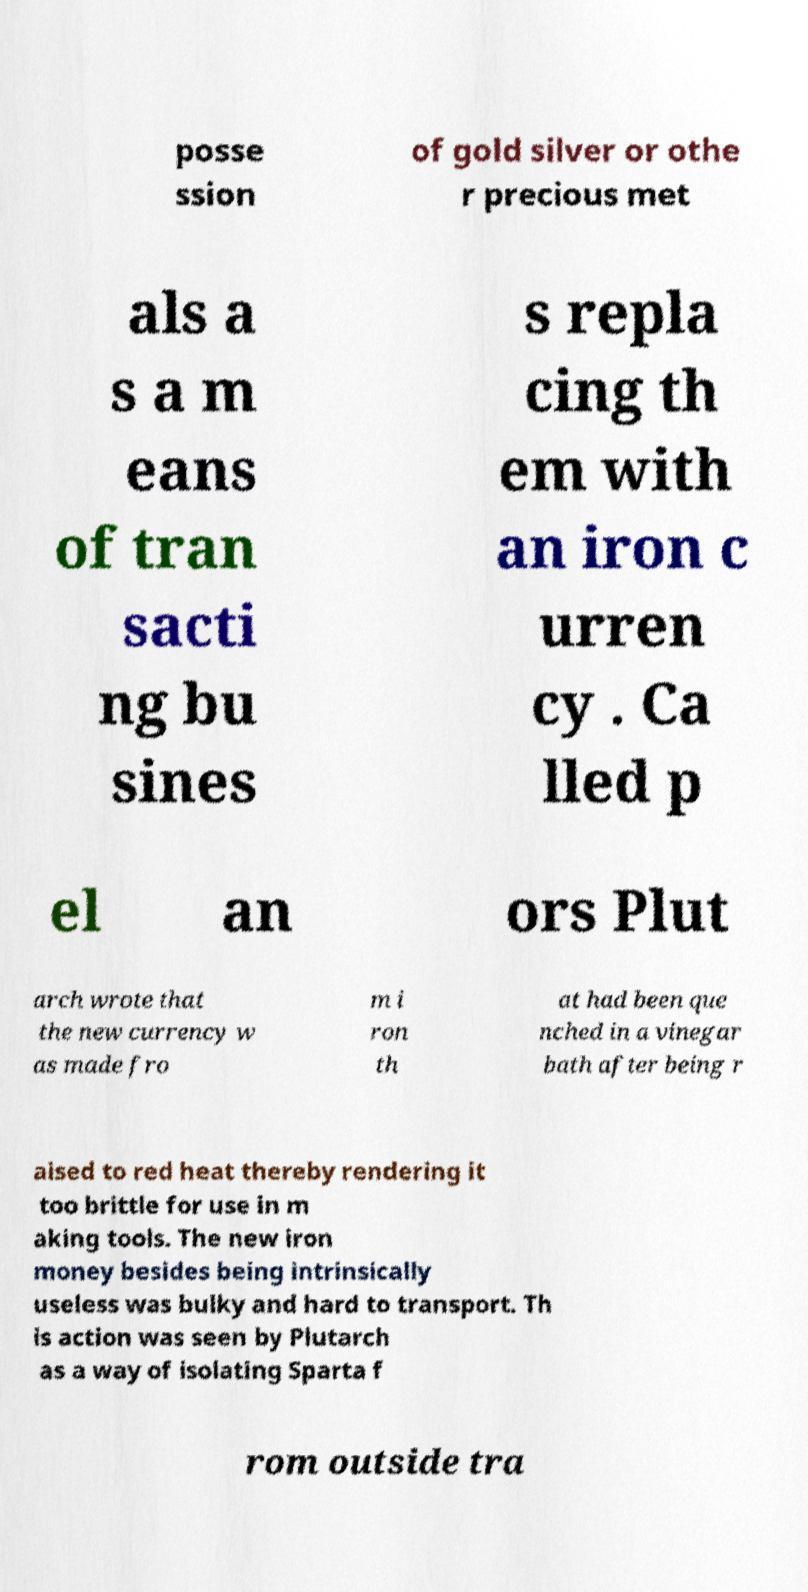Can you read and provide the text displayed in the image?This photo seems to have some interesting text. Can you extract and type it out for me? posse ssion of gold silver or othe r precious met als a s a m eans of tran sacti ng bu sines s repla cing th em with an iron c urren cy . Ca lled p el an ors Plut arch wrote that the new currency w as made fro m i ron th at had been que nched in a vinegar bath after being r aised to red heat thereby rendering it too brittle for use in m aking tools. The new iron money besides being intrinsically useless was bulky and hard to transport. Th is action was seen by Plutarch as a way of isolating Sparta f rom outside tra 